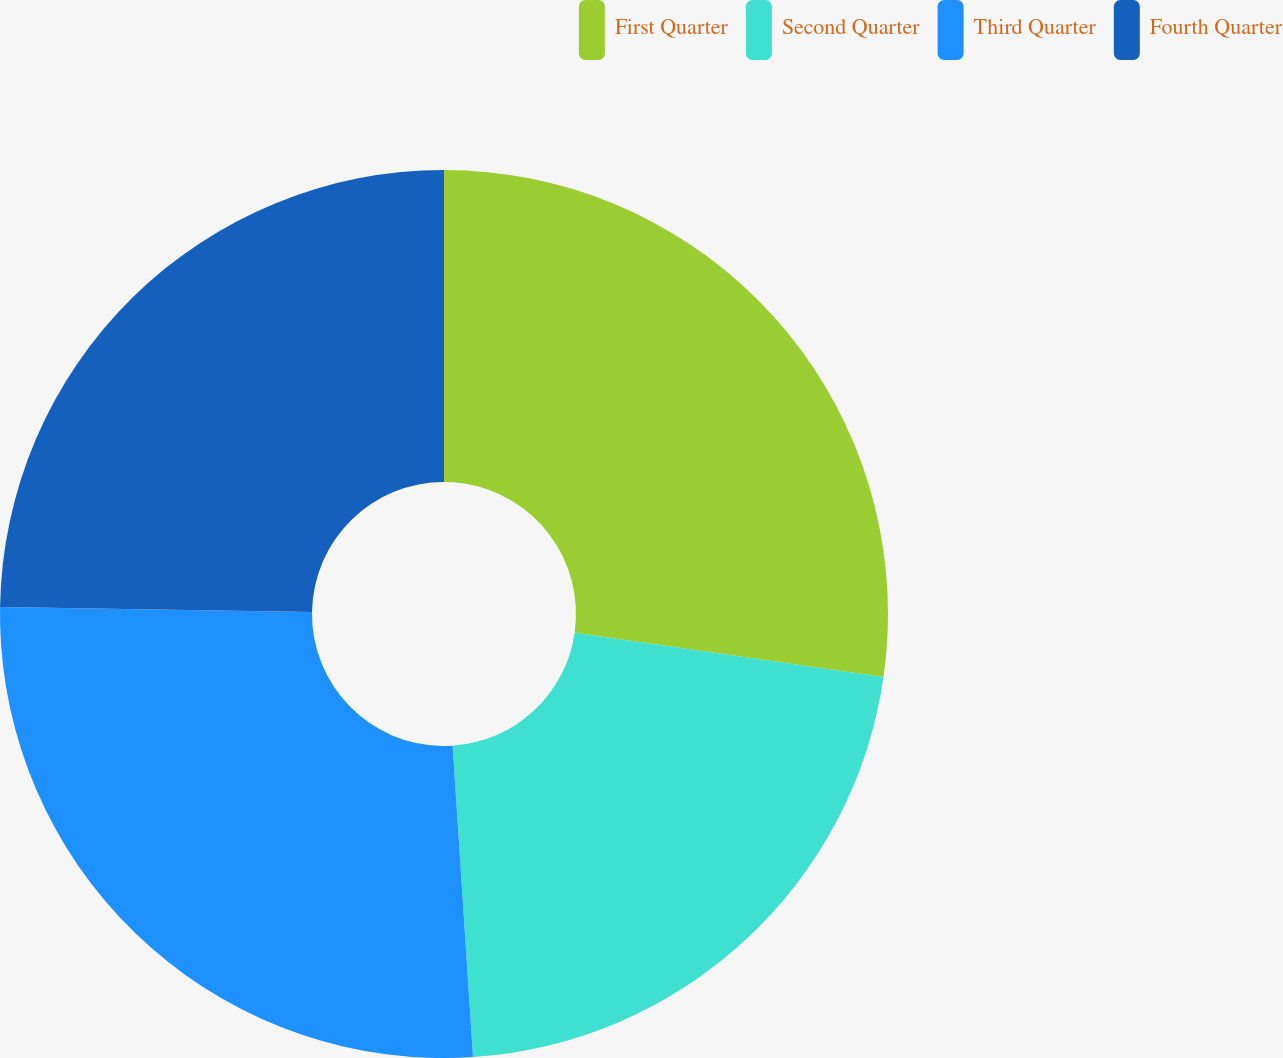Convert chart to OTSL. <chart><loc_0><loc_0><loc_500><loc_500><pie_chart><fcel>First Quarter<fcel>Second Quarter<fcel>Third Quarter<fcel>Fourth Quarter<nl><fcel>27.27%<fcel>21.69%<fcel>26.29%<fcel>24.75%<nl></chart> 